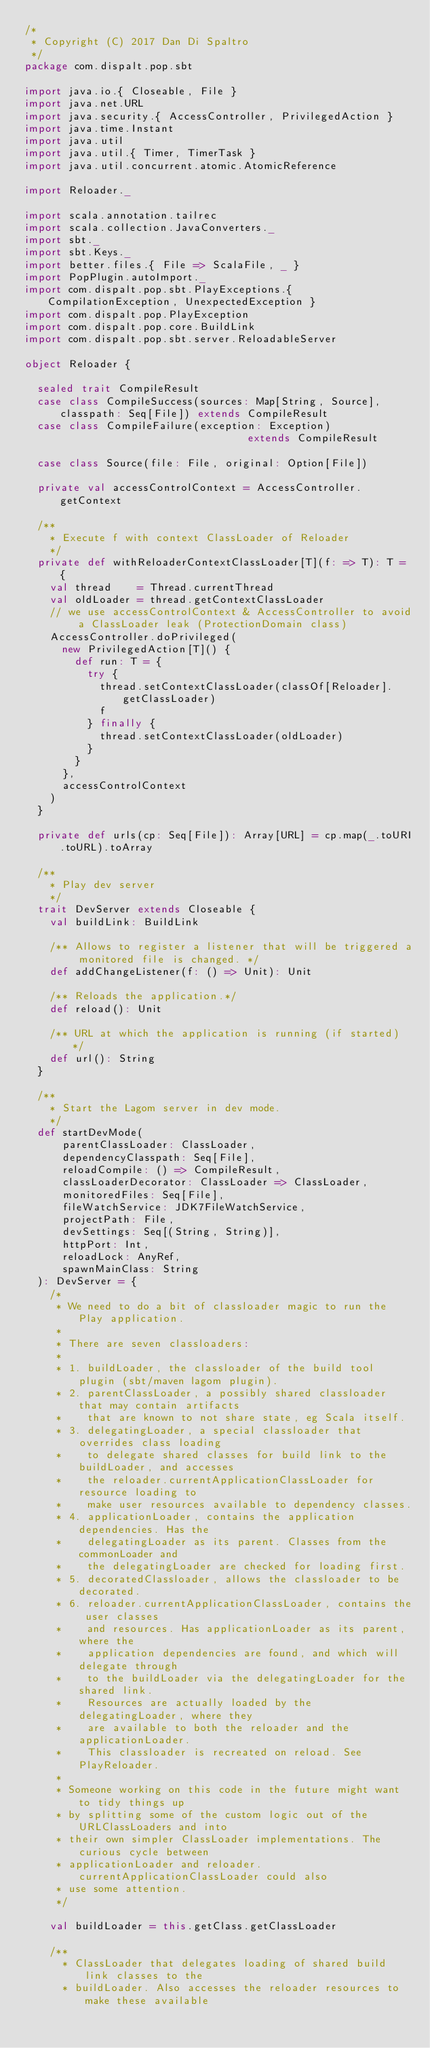<code> <loc_0><loc_0><loc_500><loc_500><_Scala_>/*
 * Copyright (C) 2017 Dan Di Spaltro
 */
package com.dispalt.pop.sbt

import java.io.{ Closeable, File }
import java.net.URL
import java.security.{ AccessController, PrivilegedAction }
import java.time.Instant
import java.util
import java.util.{ Timer, TimerTask }
import java.util.concurrent.atomic.AtomicReference

import Reloader._

import scala.annotation.tailrec
import scala.collection.JavaConverters._
import sbt._
import sbt.Keys._
import better.files.{ File => ScalaFile, _ }
import PopPlugin.autoImport._
import com.dispalt.pop.sbt.PlayExceptions.{ CompilationException, UnexpectedException }
import com.dispalt.pop.PlayException
import com.dispalt.pop.core.BuildLink
import com.dispalt.pop.sbt.server.ReloadableServer

object Reloader {

  sealed trait CompileResult
  case class CompileSuccess(sources: Map[String, Source], classpath: Seq[File]) extends CompileResult
  case class CompileFailure(exception: Exception)                               extends CompileResult

  case class Source(file: File, original: Option[File])

  private val accessControlContext = AccessController.getContext

  /**
    * Execute f with context ClassLoader of Reloader
    */
  private def withReloaderContextClassLoader[T](f: => T): T = {
    val thread    = Thread.currentThread
    val oldLoader = thread.getContextClassLoader
    // we use accessControlContext & AccessController to avoid a ClassLoader leak (ProtectionDomain class)
    AccessController.doPrivileged(
      new PrivilegedAction[T]() {
        def run: T = {
          try {
            thread.setContextClassLoader(classOf[Reloader].getClassLoader)
            f
          } finally {
            thread.setContextClassLoader(oldLoader)
          }
        }
      },
      accessControlContext
    )
  }

  private def urls(cp: Seq[File]): Array[URL] = cp.map(_.toURI.toURL).toArray

  /**
    * Play dev server
    */
  trait DevServer extends Closeable {
    val buildLink: BuildLink

    /** Allows to register a listener that will be triggered a monitored file is changed. */
    def addChangeListener(f: () => Unit): Unit

    /** Reloads the application.*/
    def reload(): Unit

    /** URL at which the application is running (if started) */
    def url(): String
  }

  /**
    * Start the Lagom server in dev mode.
    */
  def startDevMode(
      parentClassLoader: ClassLoader,
      dependencyClasspath: Seq[File],
      reloadCompile: () => CompileResult,
      classLoaderDecorator: ClassLoader => ClassLoader,
      monitoredFiles: Seq[File],
      fileWatchService: JDK7FileWatchService,
      projectPath: File,
      devSettings: Seq[(String, String)],
      httpPort: Int,
      reloadLock: AnyRef,
      spawnMainClass: String
  ): DevServer = {
    /*
     * We need to do a bit of classloader magic to run the Play application.
     *
     * There are seven classloaders:
     *
     * 1. buildLoader, the classloader of the build tool plugin (sbt/maven lagom plugin).
     * 2. parentClassLoader, a possibly shared classloader that may contain artifacts
     *    that are known to not share state, eg Scala itself.
     * 3. delegatingLoader, a special classloader that overrides class loading
     *    to delegate shared classes for build link to the buildLoader, and accesses
     *    the reloader.currentApplicationClassLoader for resource loading to
     *    make user resources available to dependency classes.
     * 4. applicationLoader, contains the application dependencies. Has the
     *    delegatingLoader as its parent. Classes from the commonLoader and
     *    the delegatingLoader are checked for loading first.
     * 5. decoratedClassloader, allows the classloader to be decorated.
     * 6. reloader.currentApplicationClassLoader, contains the user classes
     *    and resources. Has applicationLoader as its parent, where the
     *    application dependencies are found, and which will delegate through
     *    to the buildLoader via the delegatingLoader for the shared link.
     *    Resources are actually loaded by the delegatingLoader, where they
     *    are available to both the reloader and the applicationLoader.
     *    This classloader is recreated on reload. See PlayReloader.
     *
     * Someone working on this code in the future might want to tidy things up
     * by splitting some of the custom logic out of the URLClassLoaders and into
     * their own simpler ClassLoader implementations. The curious cycle between
     * applicationLoader and reloader.currentApplicationClassLoader could also
     * use some attention.
     */

    val buildLoader = this.getClass.getClassLoader

    /**
      * ClassLoader that delegates loading of shared build link classes to the
      * buildLoader. Also accesses the reloader resources to make these available</code> 